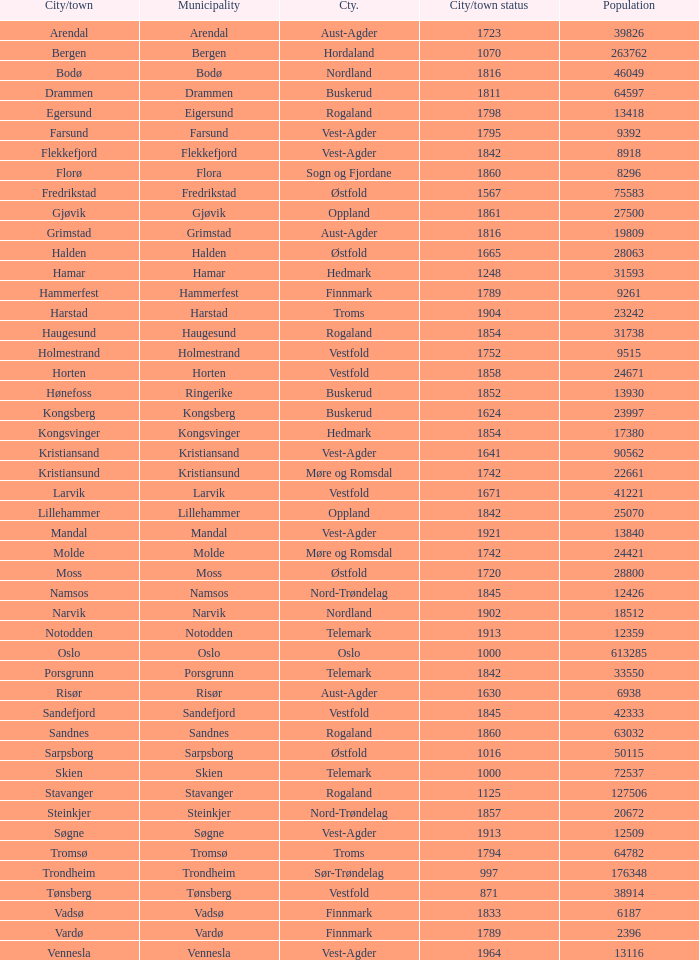In which county is the city/town of Halden located? Østfold. 